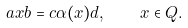Convert formula to latex. <formula><loc_0><loc_0><loc_500><loc_500>a x b = c \alpha ( x ) d , \quad x \in Q .</formula> 